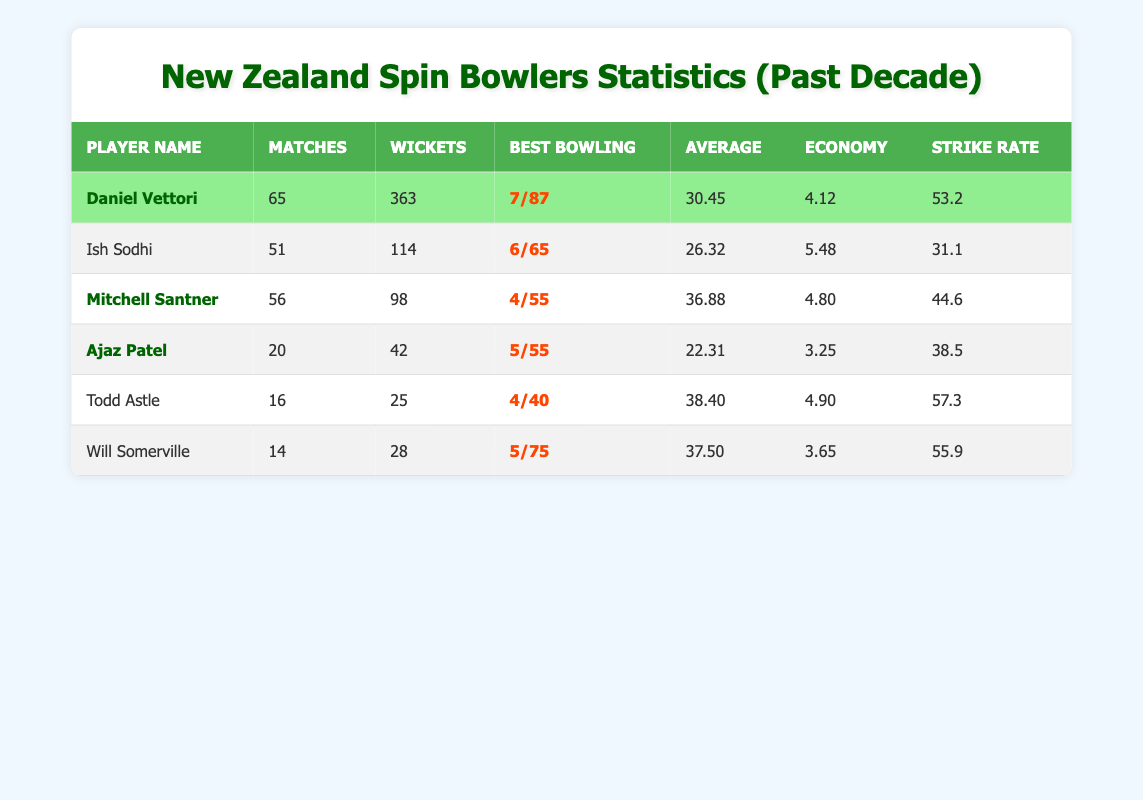What is Daniel Vettori's best bowling figure? The best bowling figure for Daniel Vettori, as shown in the table, is displayed next to his name in the "Best Bowling" column. It reads "7/87."
Answer: 7/87 How many matches did Ish Sodhi play? The number of matches played by Ish Sodhi is indicated in the "Matches" column next to his name. He played 51 matches.
Answer: 51 Who has the best bowling average among the listed players? To find the best bowling average, we compare the averages in the "Average" column. Ajaz Patel has the lowest average at 22.31, which indicates the best performance.
Answer: Ajaz Patel What is the total number of wickets taken by all the bowlers combined? We add the wickets from each player: 363 + 114 + 98 + 42 + 25 + 28 = 670. This total represents the combined wickets taken.
Answer: 670 Which player has the highest economy rate? By examining the "Economy" column, we identify the highest value. Ish Sodhi has an economy rate of 5.48, which is the highest among all players listed.
Answer: Ish Sodhi Was Todd Astle part of the New Zealand national team during the last decade? We check the "ndc" column for Todd Astle. Since his entry reads "false," he was not part of the New Zealand national team during that period.
Answer: No What is the difference in strike rate between Daniel Vettori and Mitchell Santner? We subtract Mitchell Santner's strike rate (44.6) from Daniel Vettori's strike rate (53.2): 53.2 - 44.6 = 8.6. This indicates how much higher Vettori's strike rate is compared to Santner's.
Answer: 8.6 Who among the players listed had the most matches played? In the "Matches" column, we find Daniel Vettori has the most matches with a total of 65.
Answer: Daniel Vettori Calculate the average number of wickets taken per match for Ajaz Patel. To calculate the average, we divide Ajaz Patel's total wickets (42) by his total matches (20): 42/20 = 2.1. This tells us how many wickets he took on average per match.
Answer: 2.1 Are there any players with more than 300 wickets? Checking the "Wickets" column, only Daniel Vettori has more than 300 wickets, specifically 363. Therefore, the answer is yes, he qualifies.
Answer: Yes 